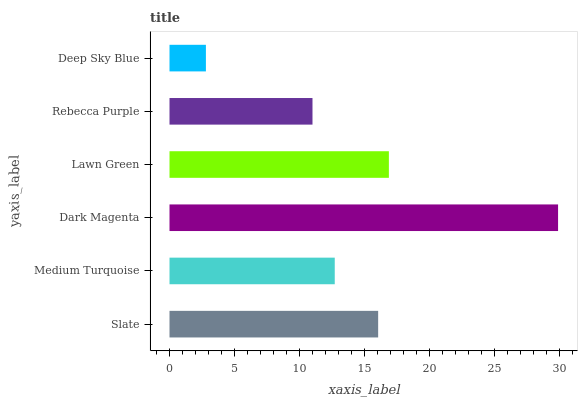Is Deep Sky Blue the minimum?
Answer yes or no. Yes. Is Dark Magenta the maximum?
Answer yes or no. Yes. Is Medium Turquoise the minimum?
Answer yes or no. No. Is Medium Turquoise the maximum?
Answer yes or no. No. Is Slate greater than Medium Turquoise?
Answer yes or no. Yes. Is Medium Turquoise less than Slate?
Answer yes or no. Yes. Is Medium Turquoise greater than Slate?
Answer yes or no. No. Is Slate less than Medium Turquoise?
Answer yes or no. No. Is Slate the high median?
Answer yes or no. Yes. Is Medium Turquoise the low median?
Answer yes or no. Yes. Is Deep Sky Blue the high median?
Answer yes or no. No. Is Dark Magenta the low median?
Answer yes or no. No. 